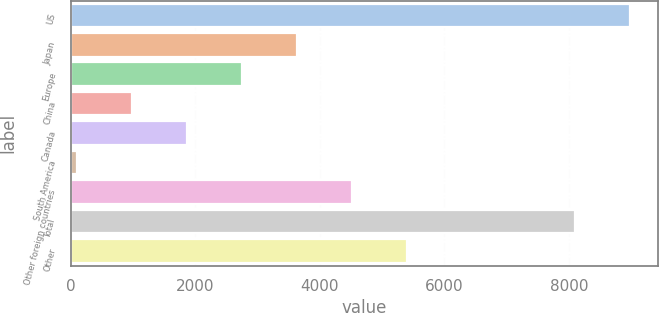Convert chart. <chart><loc_0><loc_0><loc_500><loc_500><bar_chart><fcel>US<fcel>Japan<fcel>Europe<fcel>China<fcel>Canada<fcel>South America<fcel>Other foreign countries<fcel>Total<fcel>Other<nl><fcel>8983<fcel>3634<fcel>2751<fcel>985<fcel>1868<fcel>102<fcel>4517<fcel>8100<fcel>5400<nl></chart> 